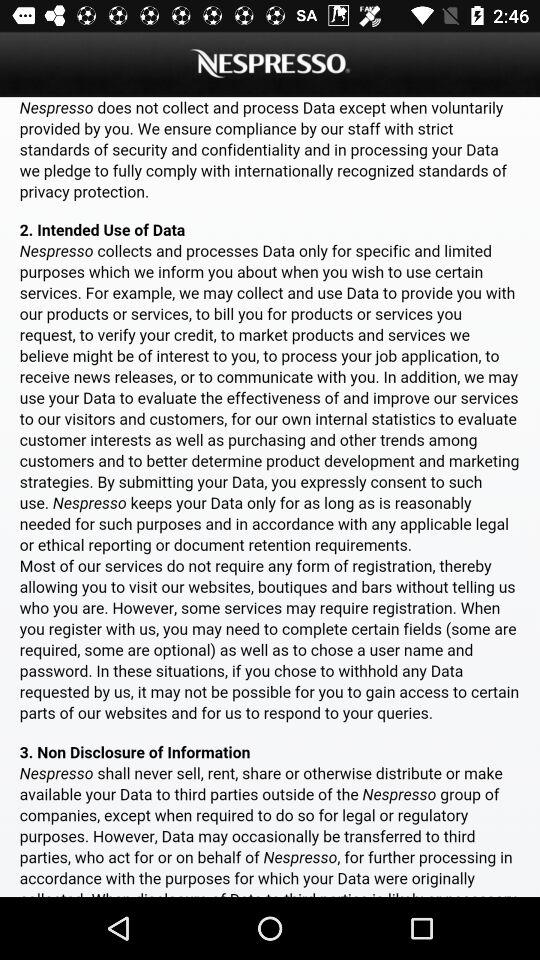What is the app name? The app name is "NESPRESSO". 